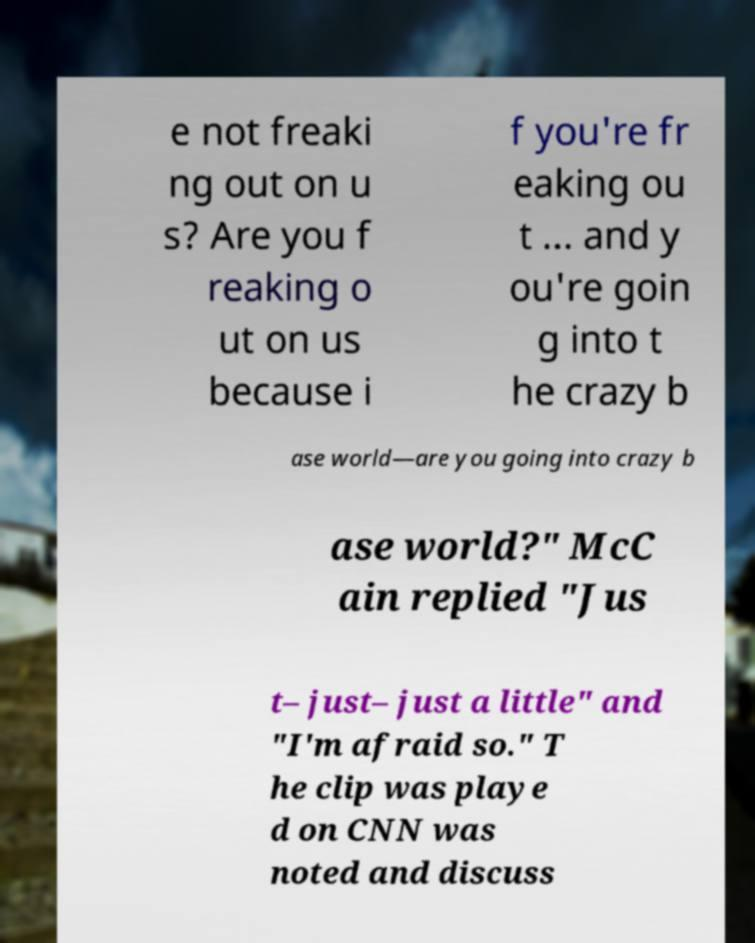There's text embedded in this image that I need extracted. Can you transcribe it verbatim? e not freaki ng out on u s? Are you f reaking o ut on us because i f you're fr eaking ou t ... and y ou're goin g into t he crazy b ase world—are you going into crazy b ase world?" McC ain replied "Jus t– just– just a little" and "I'm afraid so." T he clip was playe d on CNN was noted and discuss 